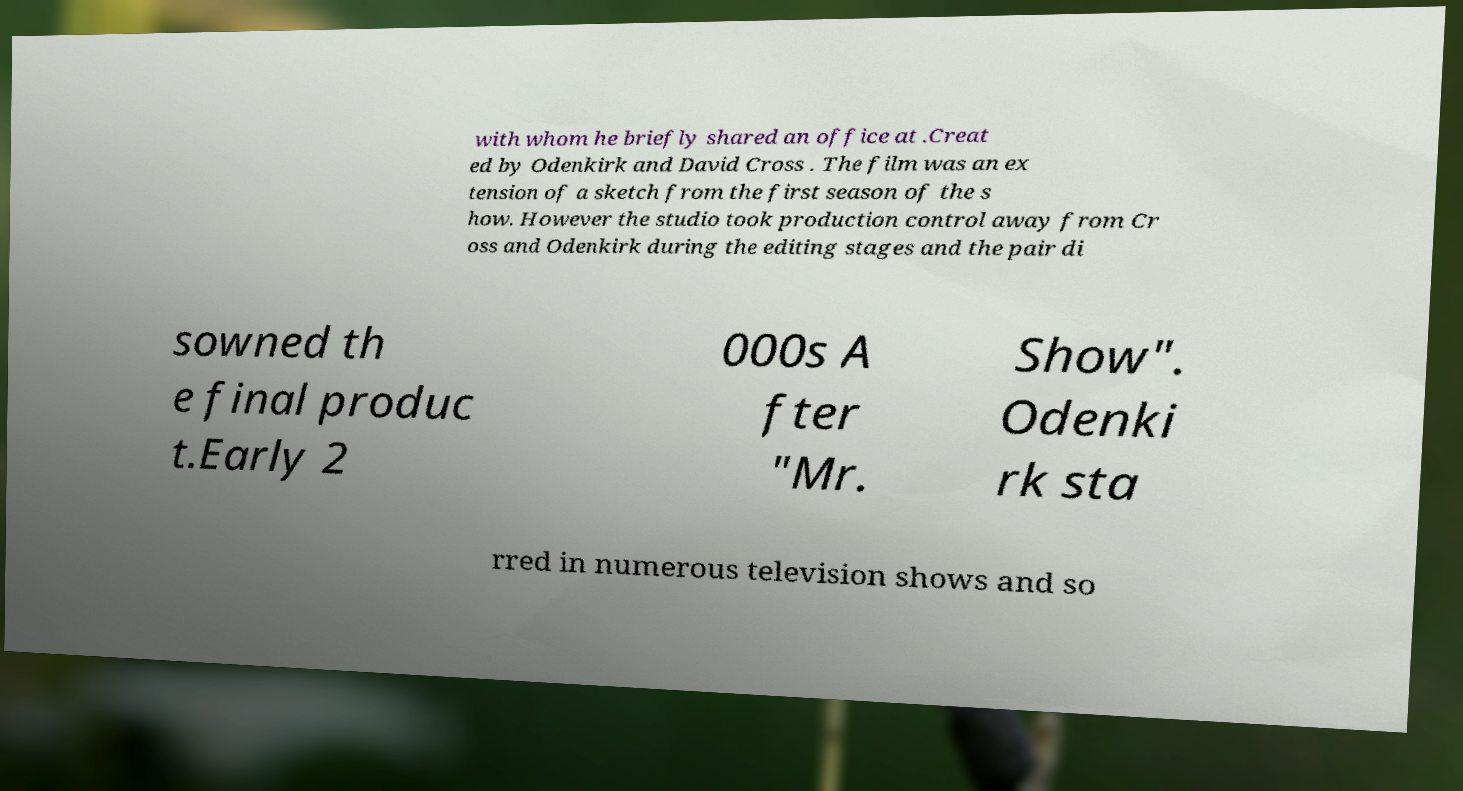Could you extract and type out the text from this image? with whom he briefly shared an office at .Creat ed by Odenkirk and David Cross . The film was an ex tension of a sketch from the first season of the s how. However the studio took production control away from Cr oss and Odenkirk during the editing stages and the pair di sowned th e final produc t.Early 2 000s A fter "Mr. Show". Odenki rk sta rred in numerous television shows and so 